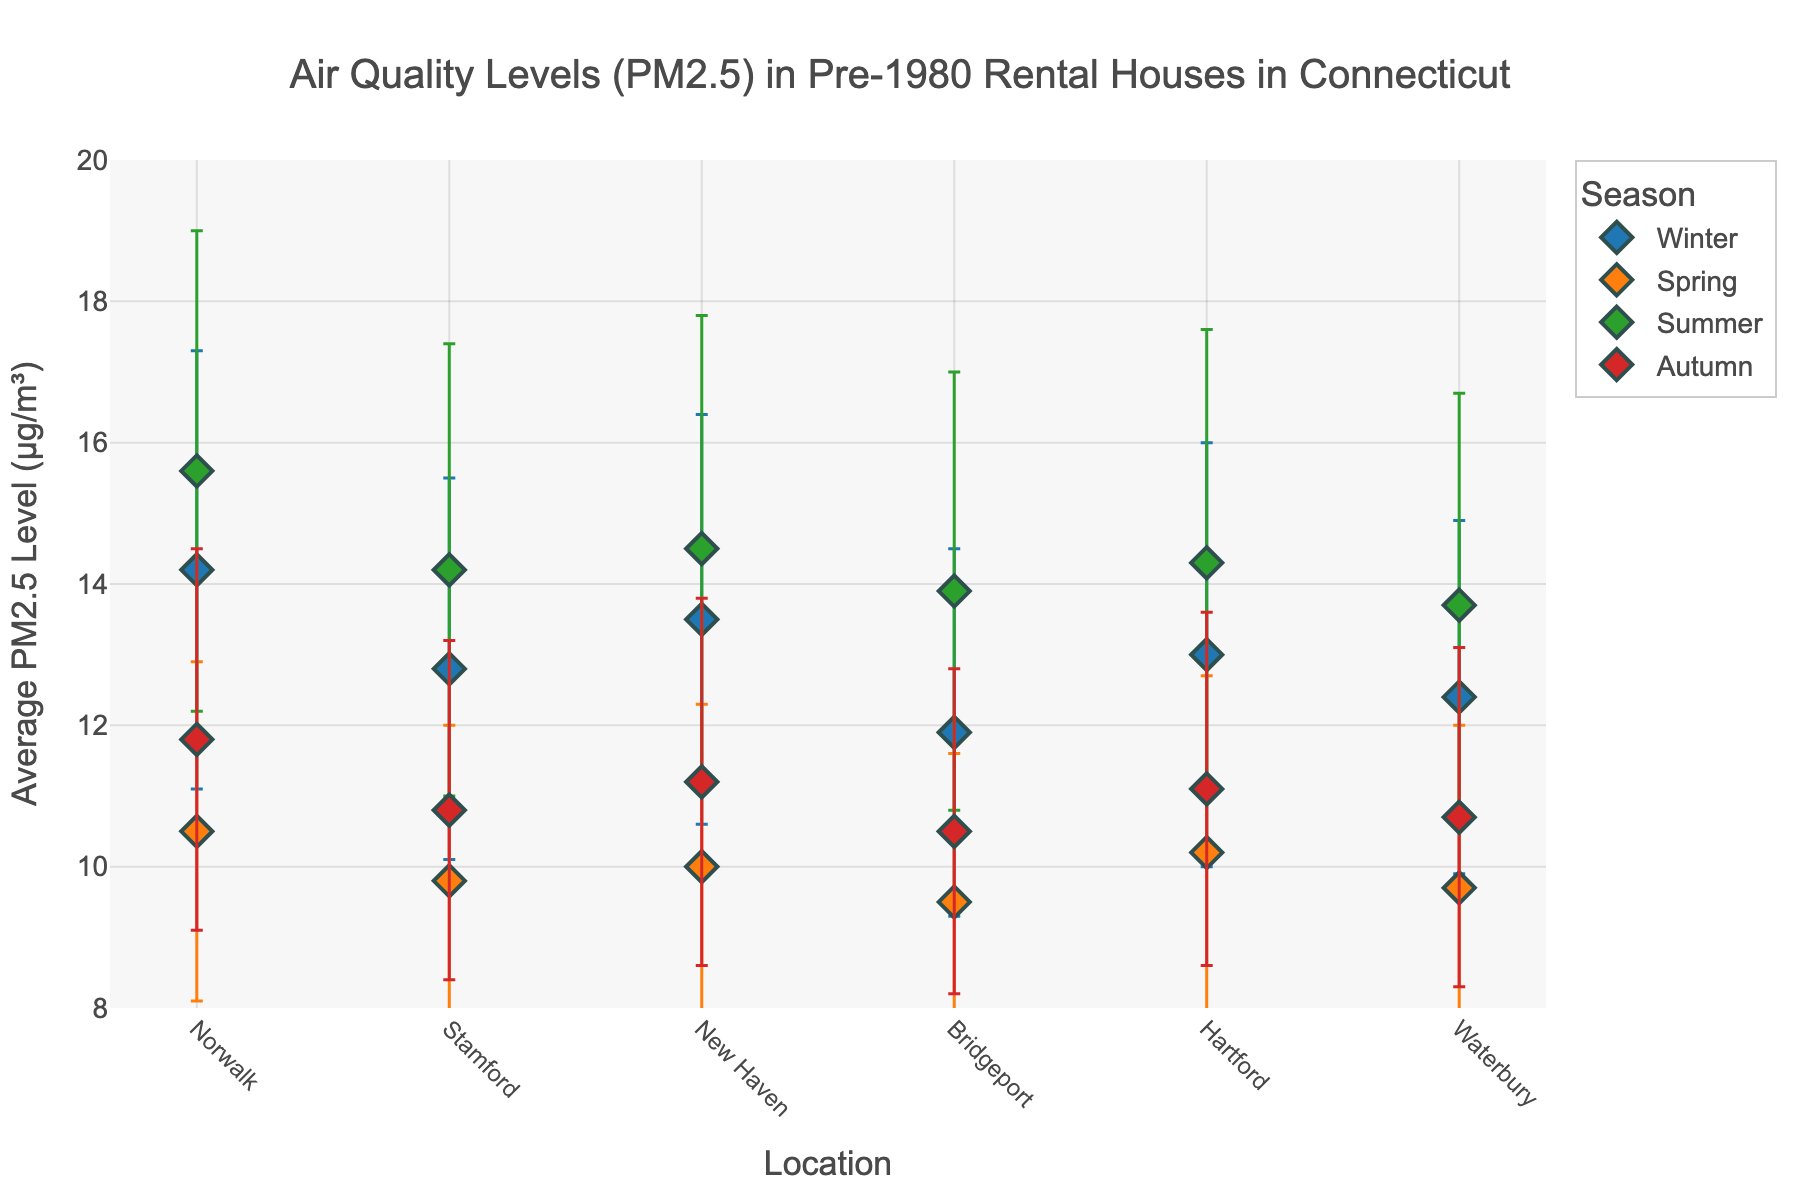What's the title of the figure? The title is usually located at the top of the figure and represents the main subject of the data visualization.
Answer: Air Quality Levels (PM2.5) in Pre-1980 Rental Houses in Connecticut What is the range of the y-axis? The y-axis range is indicated by the minimum and maximum values along this axis. From the figure, the y-axis ranges from 8 to 20.
Answer: 8 to 20 Which location has the highest PM2.5 level in the summer? Look for the dot that represents the summer season and has the highest value on the y-axis. Norwalk has the highest PM2.5 level in summer at 15.6.
Answer: Norwalk How many seasons are represented in the figure? The legend or the distinct colors correspond to different seasons. There are four distinct seasons (Winter, Spring, Summer, Autumn).
Answer: 4 In which season does Bridgeport have the lowest PM2.5 level? Compare the PM2.5 levels for Bridgeport across different seasons. Bridgeport has the lowest PM2.5 level in the Spring at 9.5.
Answer: Spring What is the approximate error range for Hartford in the Winter? The error bars indicate the range of uncertainty around the average value. For Hartford in the Winter, the average PM2.5 level is 13.0 with an error of 3.0, so the range is from 10.0 to 16.0.
Answer: 10.0 to 16.0 What is the average PM2.5 level for Stamford in Autumn and Spring? Calculate the mean of the PM2.5 levels for Stamford in both seasons. In Autumn it's 10.8, and in Spring it's 9.8, so the average is (10.8 + 9.8) / 2 = 10.3.
Answer: 10.3 Which season shows the most variability in PM2.5 levels between locations? Larger error bars and a wider range of PM2.5 levels indicate more variability. The Summer season shows the most variability with values ranging from 13.7 to 15.6 and larger error bars.
Answer: Summer Is the PM2.5 level for New Haven higher in Winter or Autumn? Compare the y-axis values for New Haven in these two seasons. In Winter, it's 13.5 and in Autumn, it's 11.2, so it's higher in Winter.
Answer: Winter 